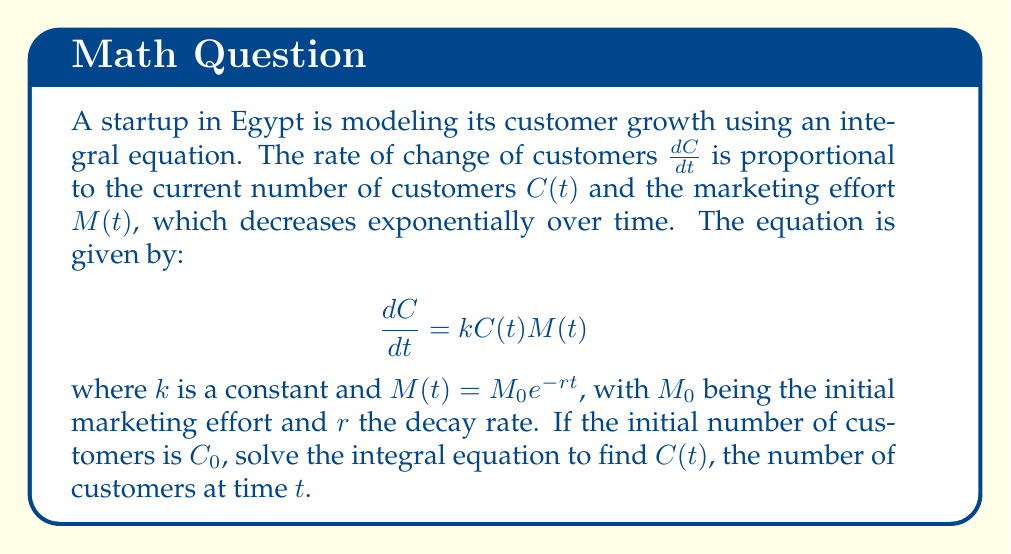Solve this math problem. Let's solve this step-by-step:

1) First, we substitute $M(t) = M_0e^{-rt}$ into the differential equation:

   $$\frac{dC}{dt} = kC(t)M_0e^{-rt}$$

2) We can separate the variables:

   $$\frac{dC}{C} = kM_0e^{-rt}dt$$

3) Now, we integrate both sides:

   $$\int \frac{dC}{C} = \int kM_0e^{-rt}dt$$

4) The left side integrates to $\ln|C|$. For the right side:

   $$\ln|C| = kM_0 \int e^{-rt}dt = -\frac{kM_0}{r}e^{-rt} + K$$

   where $K$ is a constant of integration.

5) We can simplify this to:

   $$\ln|C| = \frac{kM_0}{r}(1-e^{-rt}) + K$$

6) Now, we exponentiate both sides:

   $$C = e^{\frac{kM_0}{r}(1-e^{-rt}) + K} = Ae^{\frac{kM_0}{r}(1-e^{-rt})}$$

   where $A = e^K$ is a new constant.

7) To find $A$, we use the initial condition. At $t=0$, $C = C_0$:

   $$C_0 = Ae^{\frac{kM_0}{r}(1-e^{0})} = Ae^0 = A$$

8) Therefore, our final solution is:

   $$C(t) = C_0e^{\frac{kM_0}{r}(1-e^{-rt})}$$

This equation models the number of customers at time $t$.
Answer: $C(t) = C_0e^{\frac{kM_0}{r}(1-e^{-rt})}$ 